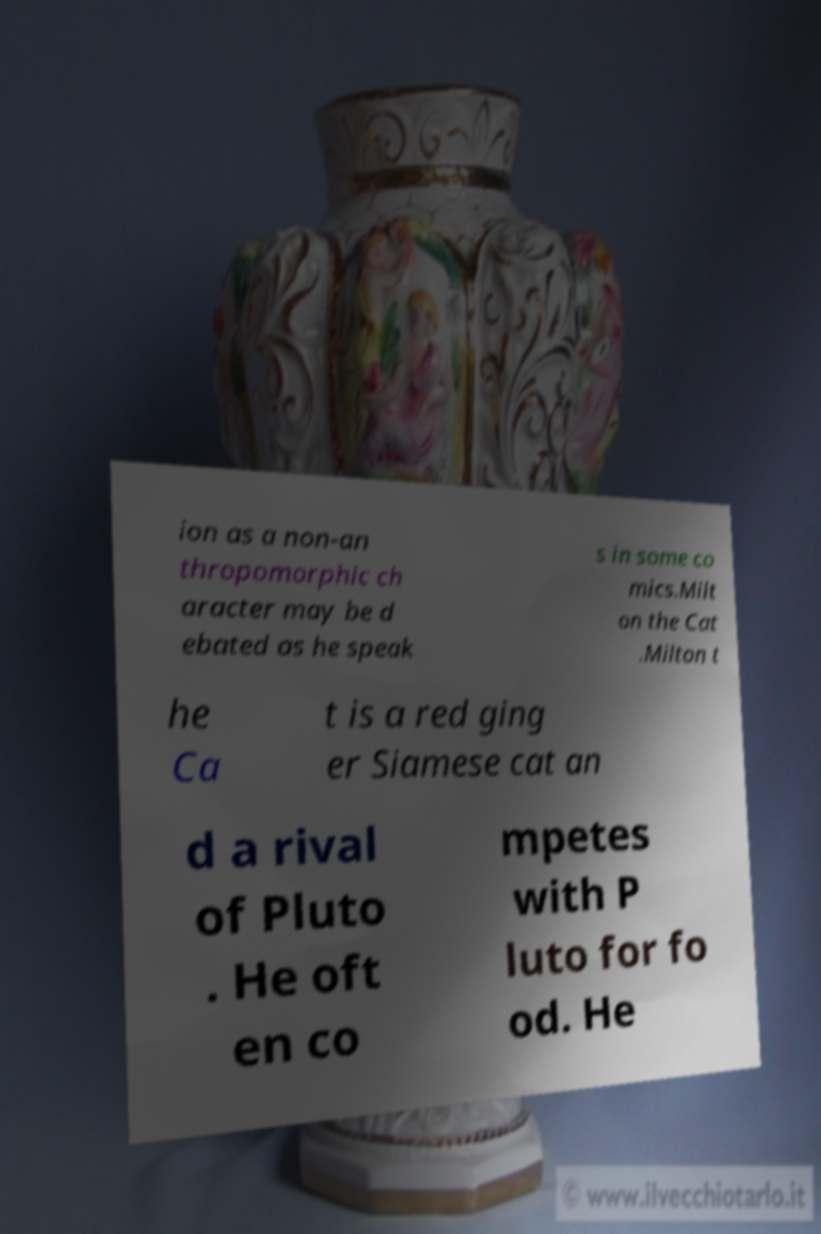Please identify and transcribe the text found in this image. ion as a non-an thropomorphic ch aracter may be d ebated as he speak s in some co mics.Milt on the Cat .Milton t he Ca t is a red ging er Siamese cat an d a rival of Pluto . He oft en co mpetes with P luto for fo od. He 